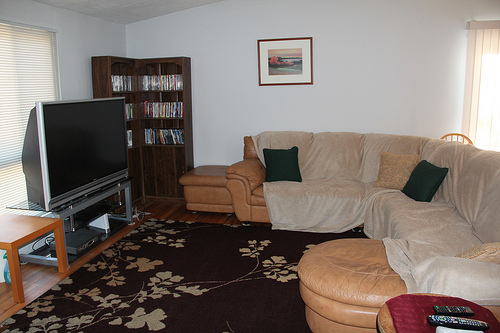Please provide a short description for this region: [0.75, 0.47, 0.84, 0.54]. The area is occupied by a small brown pillow which contributes to the cozy ambiance of the room, resting on the sofa. 